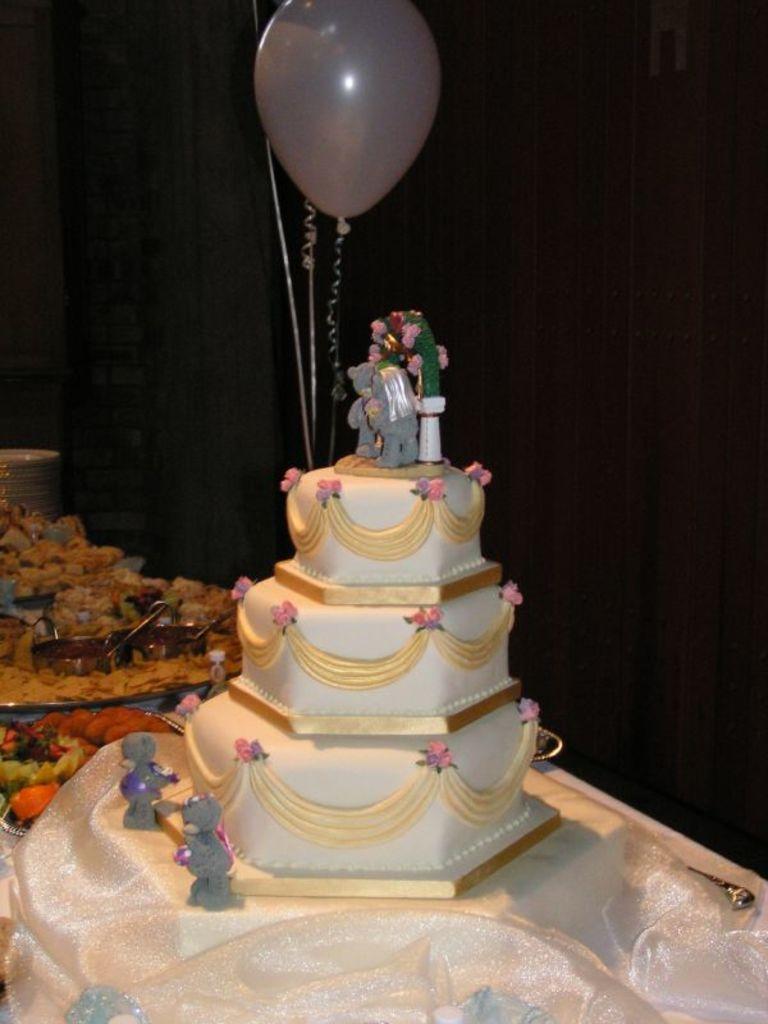Please provide a concise description of this image. In this image there is a step cake in the middle. At the top there is a balloon. On the cake there are toys. On the left side there are plates in which there are some food items. 